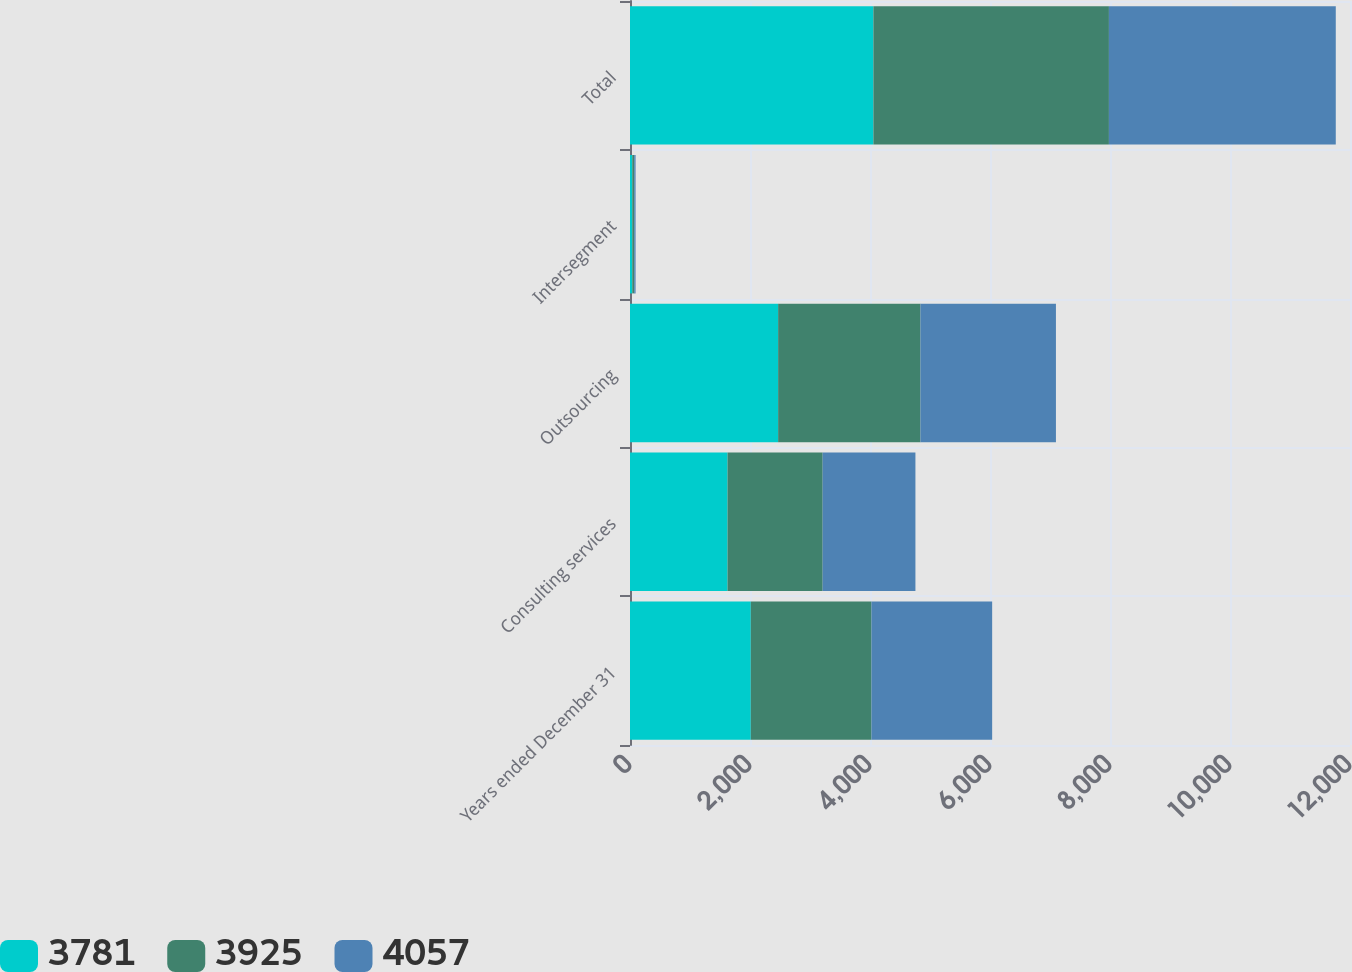Convert chart. <chart><loc_0><loc_0><loc_500><loc_500><stacked_bar_chart><ecel><fcel>Years ended December 31<fcel>Consulting services<fcel>Outsourcing<fcel>Intersegment<fcel>Total<nl><fcel>3781<fcel>2013<fcel>1626<fcel>2469<fcel>38<fcel>4057<nl><fcel>3925<fcel>2012<fcel>1585<fcel>2372<fcel>32<fcel>3925<nl><fcel>4057<fcel>2011<fcel>1546<fcel>2258<fcel>23<fcel>3781<nl></chart> 